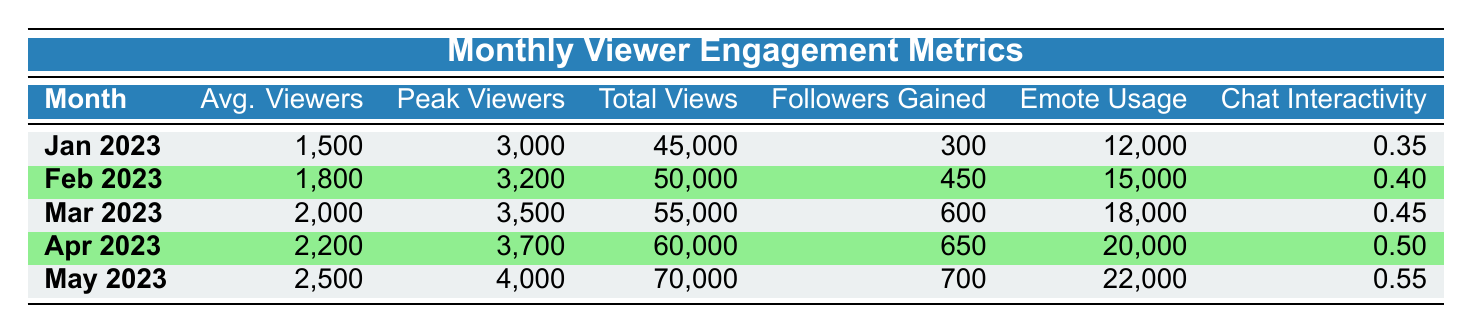What was the average number of viewers in April 2023? In the "Average_Viewers" column for April 2023, the value listed is 2200. Thus, the average number of viewers for that month is 2200.
Answer: 2200 How many total views were accumulated in February 2023? The "Total_Views" column for February 2023 shows a value of 50000. This indicates that the total views in that month were 50000.
Answer: 50000 Did the followers gained increase each month from January to May 2023? By examining the "Followers_Gained" column, the values for each month are 300, 450, 600, 650, and 700, respectively. Each value is higher than the previous one, indicating an increase each month.
Answer: Yes What is the difference between peak viewers in January 2023 and peak viewers in May 2023? The "Peak_Viewers" for January 2023 is 3000 and for May 2023 it is 4000. To find the difference, we subtract 3000 from 4000, resulting in a difference of 1000.
Answer: 1000 What was the average chat interactivity ratio across the five months? The values in the "Chat_Interactivity_Ratio" column are 0.35, 0.40, 0.45, 0.50, and 0.55. The average is calculated by adding these values (0.35 + 0.40 + 0.45 + 0.50 + 0.55 = 2.25) and dividing by the number of months (5). This results in an average of 2.25/5 = 0.45.
Answer: 0.45 What was the peak view count for March 2023? In the "Peak_Viewers" column for March 2023, the recorded peak viewer count is 3500, so that is the value for peak views in that month.
Answer: 3500 In which month was the emote usage the highest? By checking the "Emote_Usage" column, the values are 12000, 15000, 18000, 20000, and 22000 for January through May respectively. The highest value is 22000, which corresponds to May 2023.
Answer: May 2023 How much did total views increase from January 2023 to April 2023? The value for total views in January 2023 is 45000 and in April 2023 is 60000. To find the increase, we calculate 60000 - 45000, which results in an increase of 15000 total views.
Answer: 15000 